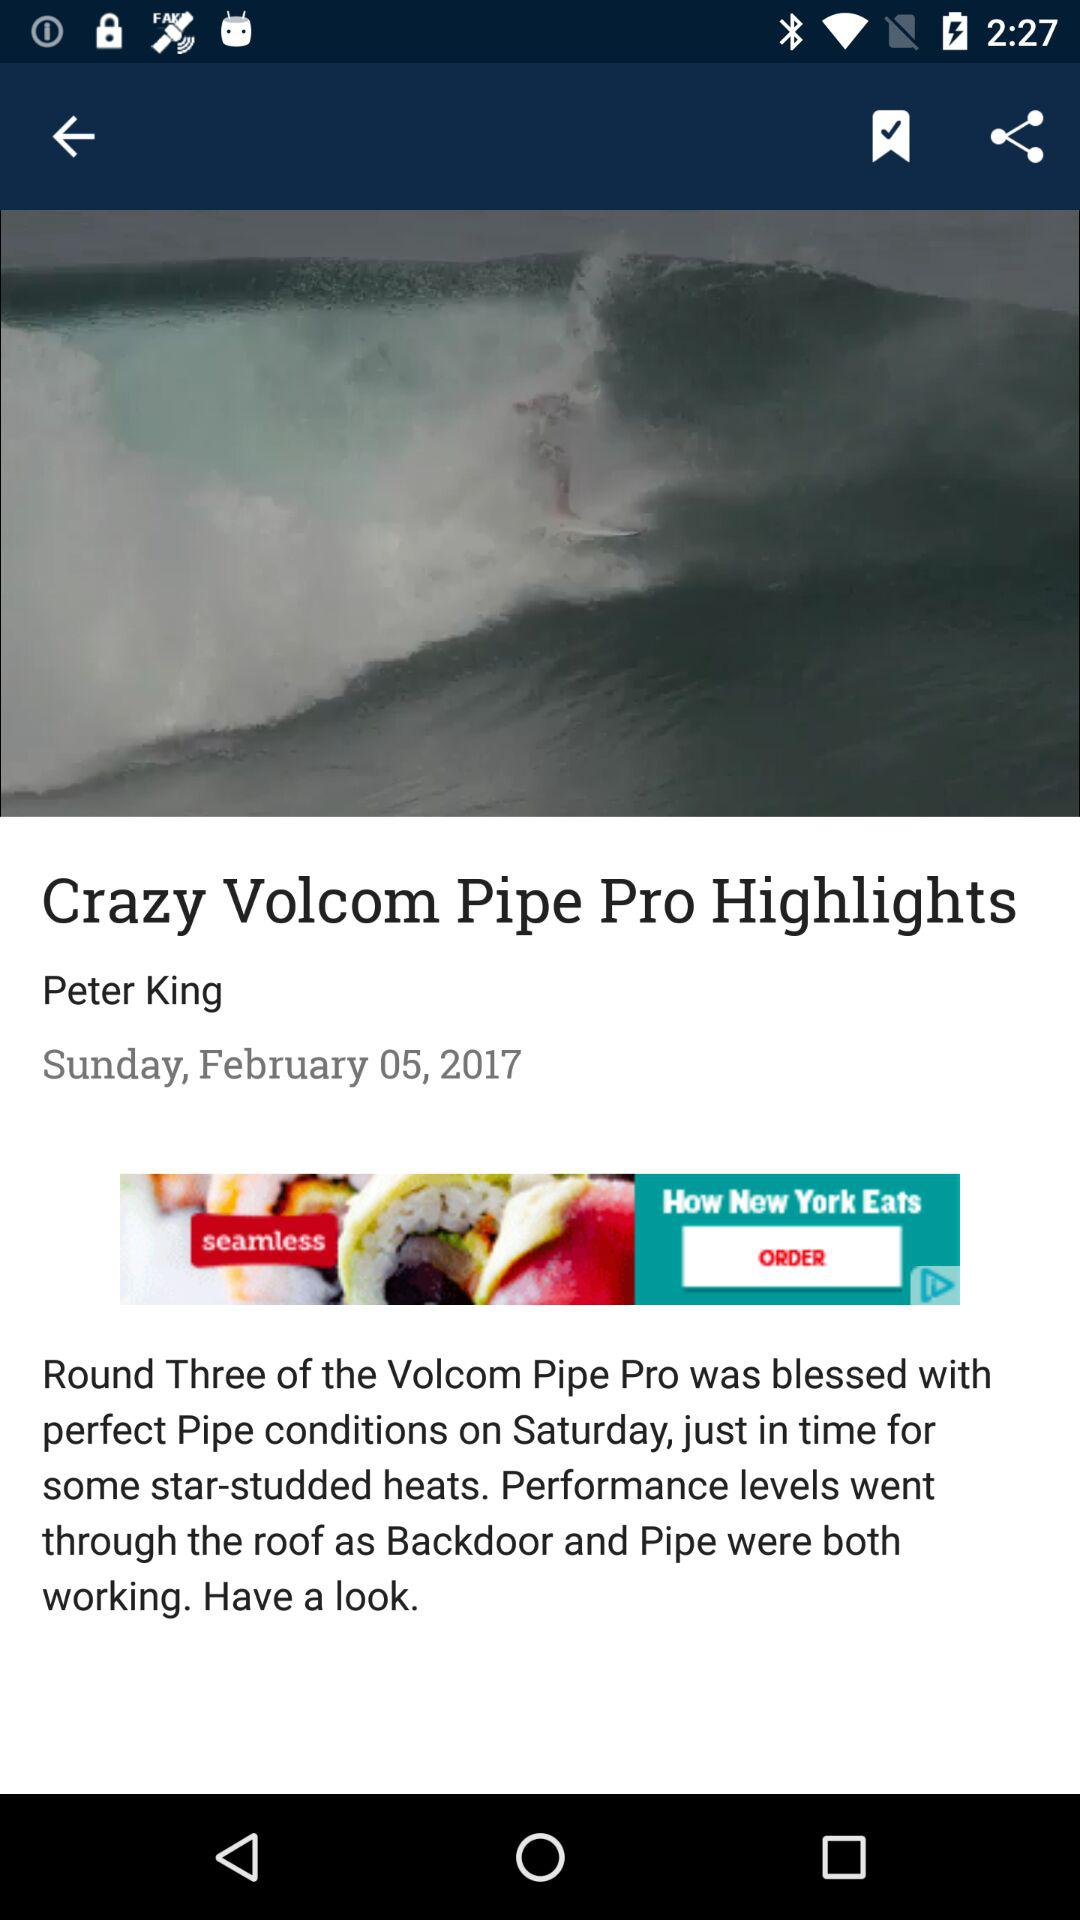Who is the author? The author is Peter King. 